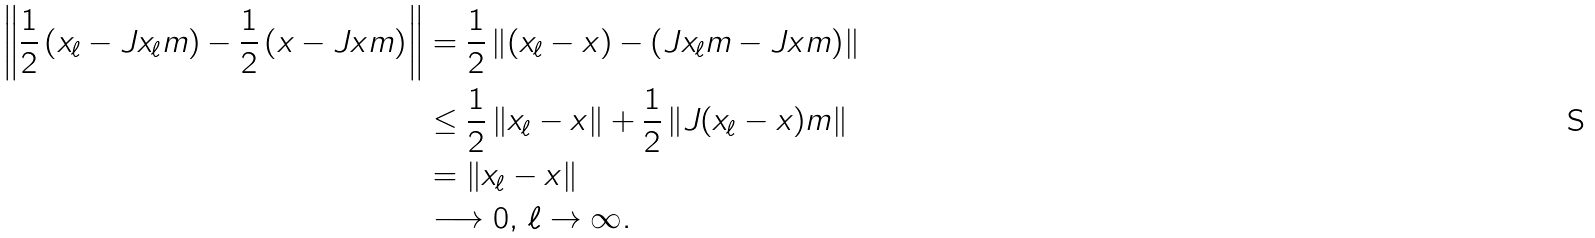<formula> <loc_0><loc_0><loc_500><loc_500>\left \| \frac { 1 } { 2 } \left ( x _ { \ell } - J x _ { \ell } m \right ) - \frac { 1 } { 2 } \left ( x - J x m \right ) \right \| & = \frac { 1 } { 2 } \left \| ( x _ { \ell } - x ) - \left ( J x _ { \ell } m - J x m \right ) \right \| \\ & \leq \frac { 1 } { 2 } \left \| x _ { \ell } - x \right \| + \frac { 1 } { 2 } \left \| J ( x _ { \ell } - x ) m \right \| \\ & = \left \| x _ { \ell } - x \right \| \\ & \longrightarrow 0 , \, \ell \to \infty .</formula> 